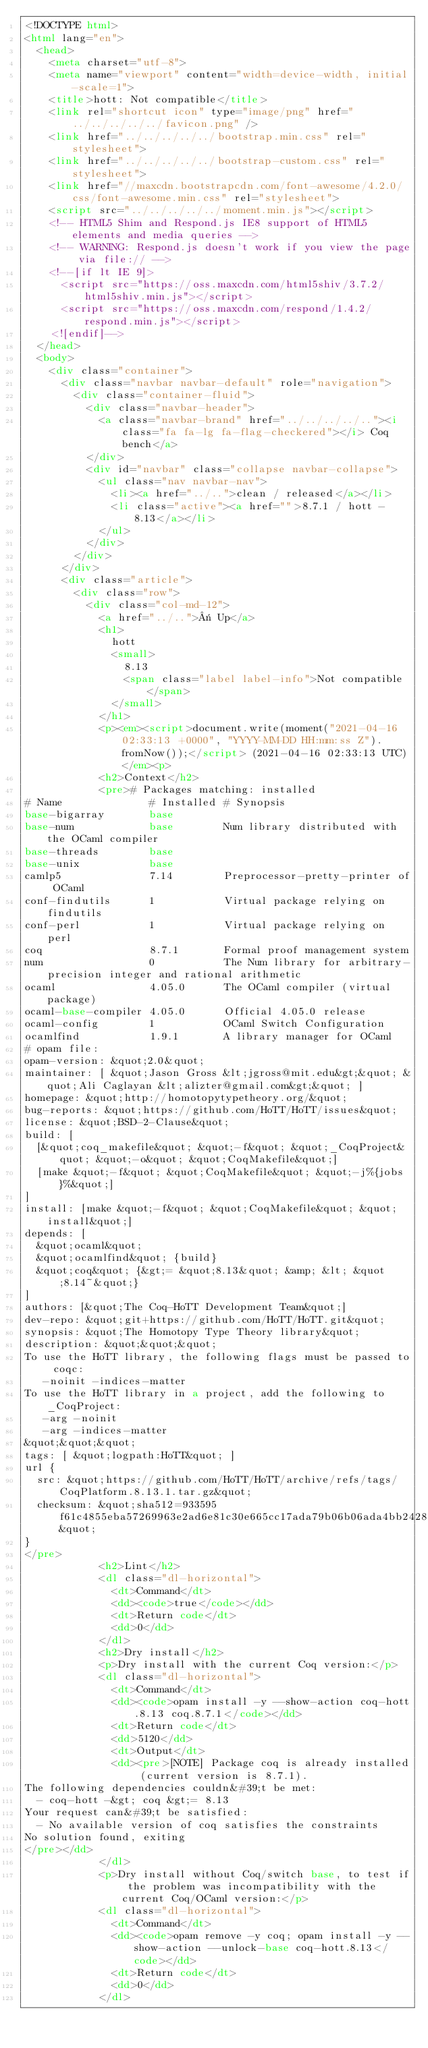Convert code to text. <code><loc_0><loc_0><loc_500><loc_500><_HTML_><!DOCTYPE html>
<html lang="en">
  <head>
    <meta charset="utf-8">
    <meta name="viewport" content="width=device-width, initial-scale=1">
    <title>hott: Not compatible</title>
    <link rel="shortcut icon" type="image/png" href="../../../../../favicon.png" />
    <link href="../../../../../bootstrap.min.css" rel="stylesheet">
    <link href="../../../../../bootstrap-custom.css" rel="stylesheet">
    <link href="//maxcdn.bootstrapcdn.com/font-awesome/4.2.0/css/font-awesome.min.css" rel="stylesheet">
    <script src="../../../../../moment.min.js"></script>
    <!-- HTML5 Shim and Respond.js IE8 support of HTML5 elements and media queries -->
    <!-- WARNING: Respond.js doesn't work if you view the page via file:// -->
    <!--[if lt IE 9]>
      <script src="https://oss.maxcdn.com/html5shiv/3.7.2/html5shiv.min.js"></script>
      <script src="https://oss.maxcdn.com/respond/1.4.2/respond.min.js"></script>
    <![endif]-->
  </head>
  <body>
    <div class="container">
      <div class="navbar navbar-default" role="navigation">
        <div class="container-fluid">
          <div class="navbar-header">
            <a class="navbar-brand" href="../../../../.."><i class="fa fa-lg fa-flag-checkered"></i> Coq bench</a>
          </div>
          <div id="navbar" class="collapse navbar-collapse">
            <ul class="nav navbar-nav">
              <li><a href="../..">clean / released</a></li>
              <li class="active"><a href="">8.7.1 / hott - 8.13</a></li>
            </ul>
          </div>
        </div>
      </div>
      <div class="article">
        <div class="row">
          <div class="col-md-12">
            <a href="../..">« Up</a>
            <h1>
              hott
              <small>
                8.13
                <span class="label label-info">Not compatible</span>
              </small>
            </h1>
            <p><em><script>document.write(moment("2021-04-16 02:33:13 +0000", "YYYY-MM-DD HH:mm:ss Z").fromNow());</script> (2021-04-16 02:33:13 UTC)</em><p>
            <h2>Context</h2>
            <pre># Packages matching: installed
# Name              # Installed # Synopsis
base-bigarray       base
base-num            base        Num library distributed with the OCaml compiler
base-threads        base
base-unix           base
camlp5              7.14        Preprocessor-pretty-printer of OCaml
conf-findutils      1           Virtual package relying on findutils
conf-perl           1           Virtual package relying on perl
coq                 8.7.1       Formal proof management system
num                 0           The Num library for arbitrary-precision integer and rational arithmetic
ocaml               4.05.0      The OCaml compiler (virtual package)
ocaml-base-compiler 4.05.0      Official 4.05.0 release
ocaml-config        1           OCaml Switch Configuration
ocamlfind           1.9.1       A library manager for OCaml
# opam file:
opam-version: &quot;2.0&quot;
maintainer: [ &quot;Jason Gross &lt;jgross@mit.edu&gt;&quot; &quot;Ali Caglayan &lt;alizter@gmail.com&gt;&quot; ]
homepage: &quot;http://homotopytypetheory.org/&quot;
bug-reports: &quot;https://github.com/HoTT/HoTT/issues&quot;
license: &quot;BSD-2-Clause&quot;
build: [
  [&quot;coq_makefile&quot; &quot;-f&quot; &quot;_CoqProject&quot; &quot;-o&quot; &quot;CoqMakefile&quot;]
  [make &quot;-f&quot; &quot;CoqMakefile&quot; &quot;-j%{jobs}%&quot;]
]
install: [make &quot;-f&quot; &quot;CoqMakefile&quot; &quot;install&quot;]
depends: [
  &quot;ocaml&quot;
  &quot;ocamlfind&quot; {build}
  &quot;coq&quot; {&gt;= &quot;8.13&quot; &amp; &lt; &quot;8.14~&quot;}
]
authors: [&quot;The Coq-HoTT Development Team&quot;]
dev-repo: &quot;git+https://github.com/HoTT/HoTT.git&quot;
synopsis: &quot;The Homotopy Type Theory library&quot;
description: &quot;&quot;&quot;
To use the HoTT library, the following flags must be passed to coqc:
   -noinit -indices-matter
To use the HoTT library in a project, add the following to _CoqProject:
   -arg -noinit
   -arg -indices-matter
&quot;&quot;&quot;
tags: [ &quot;logpath:HoTT&quot; ]
url {
  src: &quot;https://github.com/HoTT/HoTT/archive/refs/tags/CoqPlatform.8.13.1.tar.gz&quot;
  checksum: &quot;sha512=933595f61c4855eba57269963e2ad6e81c30e665cc17ada79b06b06ada4bb242881e1a5d9eafcdcad272a4d88d1e4216c3f418d4203f70301329b813da65d866&quot;
}
</pre>
            <h2>Lint</h2>
            <dl class="dl-horizontal">
              <dt>Command</dt>
              <dd><code>true</code></dd>
              <dt>Return code</dt>
              <dd>0</dd>
            </dl>
            <h2>Dry install</h2>
            <p>Dry install with the current Coq version:</p>
            <dl class="dl-horizontal">
              <dt>Command</dt>
              <dd><code>opam install -y --show-action coq-hott.8.13 coq.8.7.1</code></dd>
              <dt>Return code</dt>
              <dd>5120</dd>
              <dt>Output</dt>
              <dd><pre>[NOTE] Package coq is already installed (current version is 8.7.1).
The following dependencies couldn&#39;t be met:
  - coq-hott -&gt; coq &gt;= 8.13
Your request can&#39;t be satisfied:
  - No available version of coq satisfies the constraints
No solution found, exiting
</pre></dd>
            </dl>
            <p>Dry install without Coq/switch base, to test if the problem was incompatibility with the current Coq/OCaml version:</p>
            <dl class="dl-horizontal">
              <dt>Command</dt>
              <dd><code>opam remove -y coq; opam install -y --show-action --unlock-base coq-hott.8.13</code></dd>
              <dt>Return code</dt>
              <dd>0</dd>
            </dl></code> 